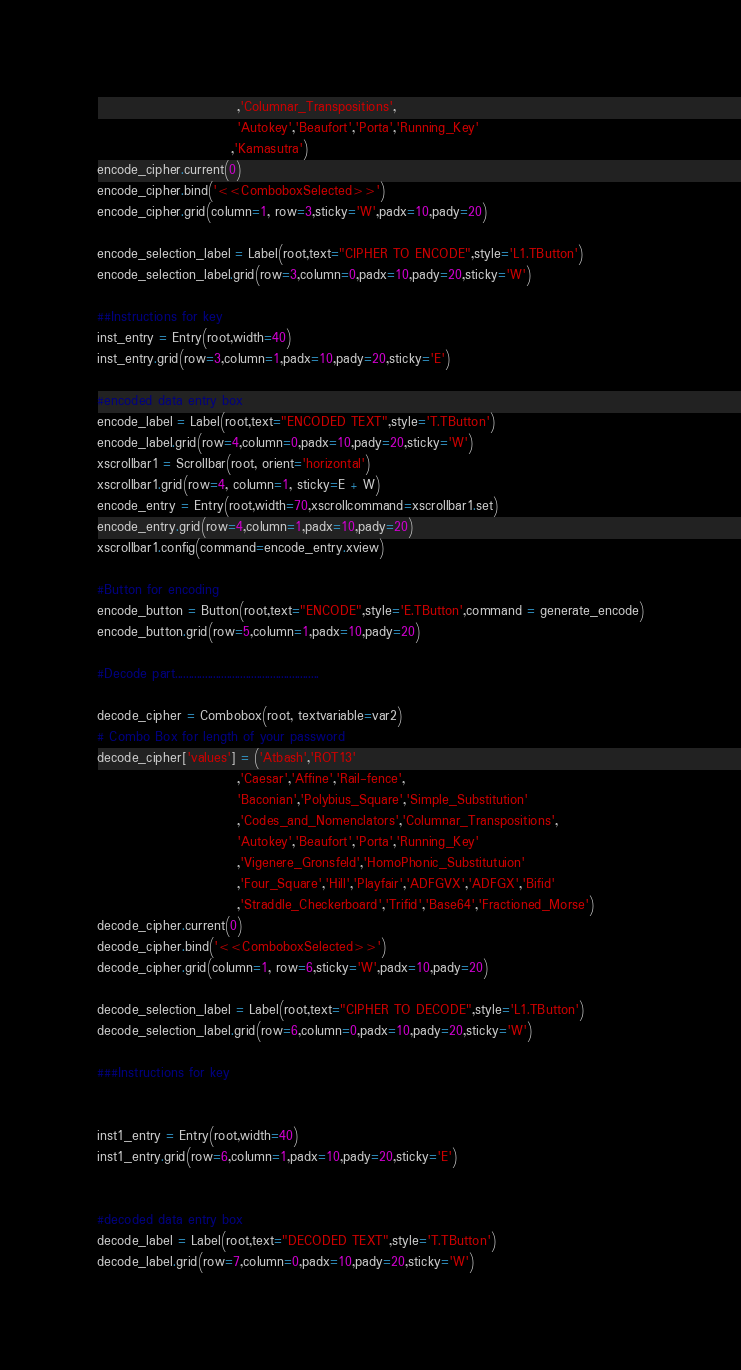Convert code to text. <code><loc_0><loc_0><loc_500><loc_500><_Python_>                           ,'Columnar_Transpositions',
                           'Autokey','Beaufort','Porta','Running_Key'
                          ,'Kamasutra')
encode_cipher.current(0)
encode_cipher.bind('<<ComboboxSelected>>')
encode_cipher.grid(column=1, row=3,sticky='W',padx=10,pady=20)

encode_selection_label = Label(root,text="CIPHER TO ENCODE",style='L1.TButton')
encode_selection_label.grid(row=3,column=0,padx=10,pady=20,sticky='W')

##Instructions for key
inst_entry = Entry(root,width=40)
inst_entry.grid(row=3,column=1,padx=10,pady=20,sticky='E')

#encoded data entry box
encode_label = Label(root,text="ENCODED TEXT",style='T.TButton')
encode_label.grid(row=4,column=0,padx=10,pady=20,sticky='W')
xscrollbar1 = Scrollbar(root, orient='horizontal')
xscrollbar1.grid(row=4, column=1, sticky=E + W)
encode_entry = Entry(root,width=70,xscrollcommand=xscrollbar1.set)
encode_entry.grid(row=4,column=1,padx=10,pady=20)
xscrollbar1.config(command=encode_entry.xview)

#Button for encoding
encode_button = Button(root,text="ENCODE",style='E.TButton',command = generate_encode)
encode_button.grid(row=5,column=1,padx=10,pady=20)

#Decode part.....................................................

decode_cipher = Combobox(root, textvariable=var2)
# Combo Box for length of your password
decode_cipher['values'] = ('Atbash','ROT13'
                           ,'Caesar','Affine','Rail-fence',
                           'Baconian','Polybius_Square','Simple_Substitution'
                           ,'Codes_and_Nomenclators','Columnar_Transpositions',
                           'Autokey','Beaufort','Porta','Running_Key'
                           ,'Vigenere_Gronsfeld','HomoPhonic_Substitutuion'
                           ,'Four_Square','Hill','Playfair','ADFGVX','ADFGX','Bifid'
                           ,'Straddle_Checkerboard','Trifid','Base64','Fractioned_Morse')
decode_cipher.current(0)
decode_cipher.bind('<<ComboboxSelected>>')
decode_cipher.grid(column=1, row=6,sticky='W',padx=10,pady=20)

decode_selection_label = Label(root,text="CIPHER TO DECODE",style='L1.TButton')
decode_selection_label.grid(row=6,column=0,padx=10,pady=20,sticky='W')

###Instructions for key


inst1_entry = Entry(root,width=40)
inst1_entry.grid(row=6,column=1,padx=10,pady=20,sticky='E')


#decoded data entry box
decode_label = Label(root,text="DECODED TEXT",style='T.TButton')
decode_label.grid(row=7,column=0,padx=10,pady=20,sticky='W')</code> 